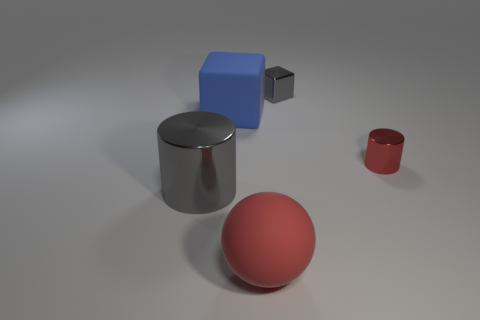Subtract 1 cubes. How many cubes are left? 1 Add 4 big gray shiny cylinders. How many objects exist? 9 Subtract all cubes. How many objects are left? 3 Add 1 red objects. How many red objects are left? 3 Add 1 small red shiny things. How many small red shiny things exist? 2 Subtract 0 yellow blocks. How many objects are left? 5 Subtract all red rubber objects. Subtract all red matte objects. How many objects are left? 3 